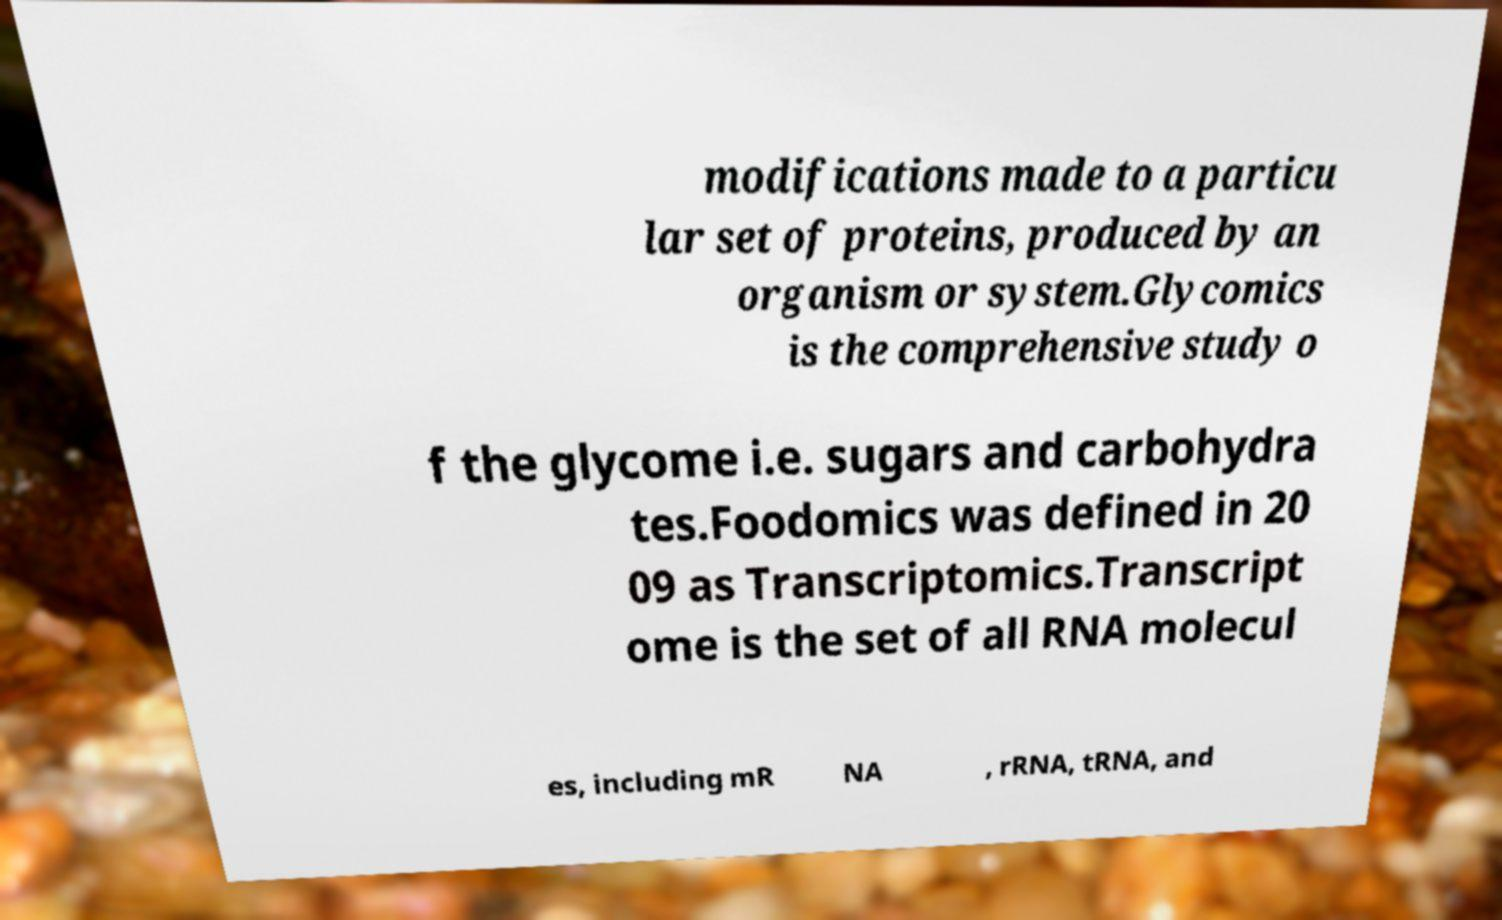Can you read and provide the text displayed in the image?This photo seems to have some interesting text. Can you extract and type it out for me? modifications made to a particu lar set of proteins, produced by an organism or system.Glycomics is the comprehensive study o f the glycome i.e. sugars and carbohydra tes.Foodomics was defined in 20 09 as Transcriptomics.Transcript ome is the set of all RNA molecul es, including mR NA , rRNA, tRNA, and 